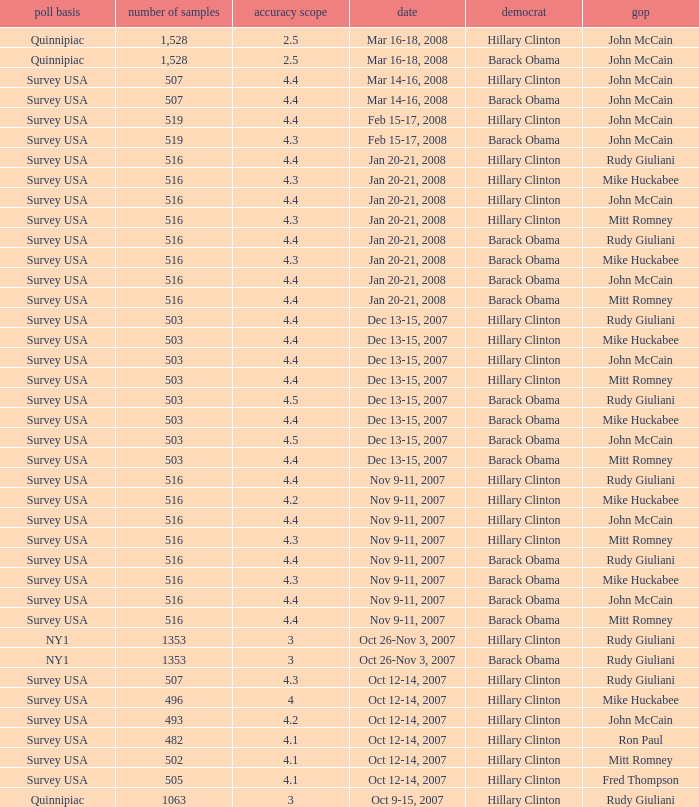What is the sample size of the poll taken on Dec 13-15, 2007 that had a margin of error of more than 4 and resulted with Republican Mike Huckabee? 503.0. 